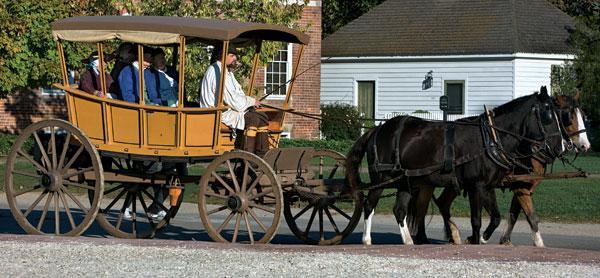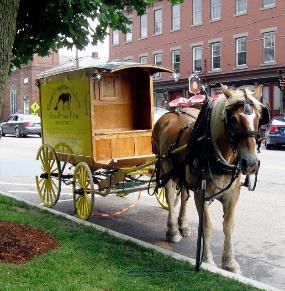The first image is the image on the left, the second image is the image on the right. For the images displayed, is the sentence "a brown horse pulls a small carriage with 2 people on it" factually correct? Answer yes or no. No. The first image is the image on the left, the second image is the image on the right. Examine the images to the left and right. Is the description "Right image shows a four-wheeled cart puled by one horse." accurate? Answer yes or no. Yes. 